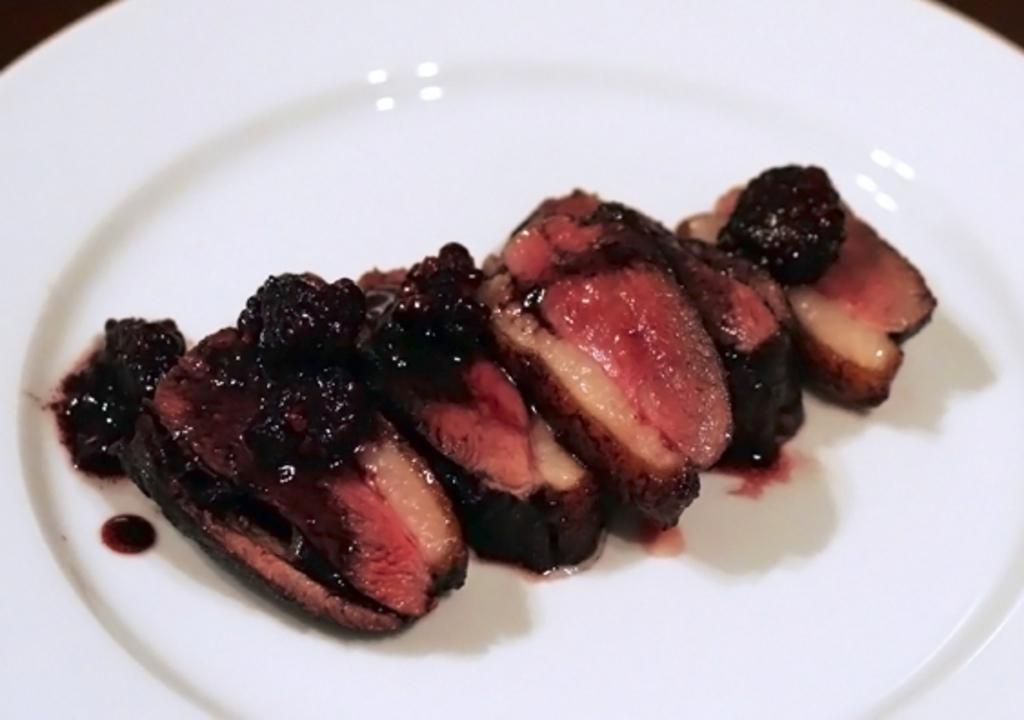Please provide a concise description of this image. In the center of this picture we can see a white color palette containing some food items. 